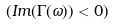Convert formula to latex. <formula><loc_0><loc_0><loc_500><loc_500>( I m ( \Gamma ( \omega ) ) < 0 )</formula> 